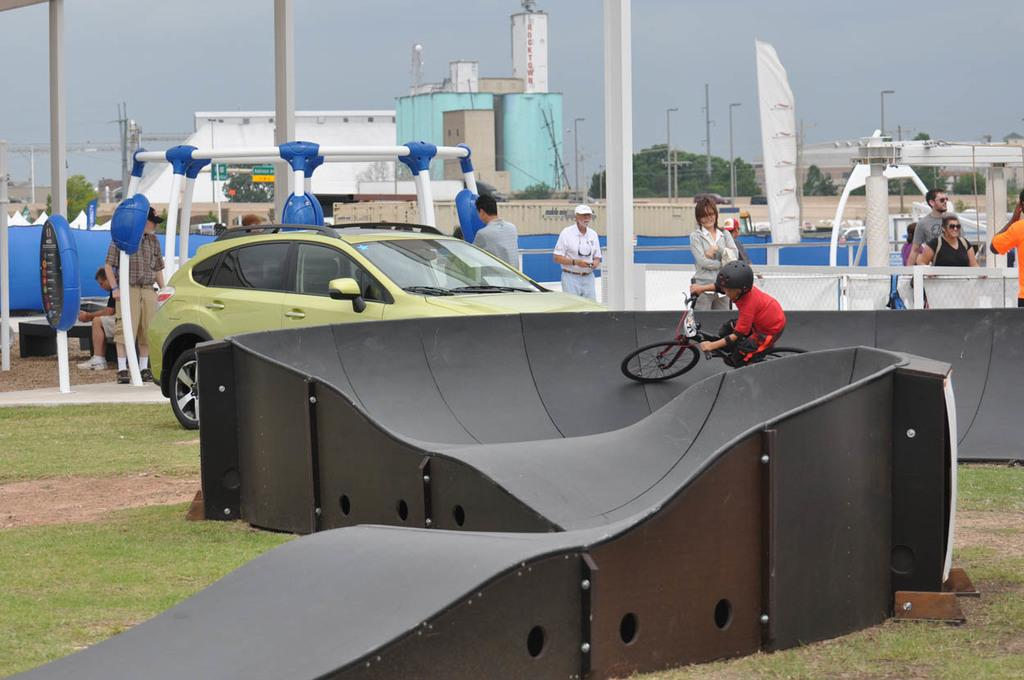What is the main subject of the image? The main subject of the image is a small boy. What is the boy doing in the image? The boy is riding a bicycle in the image. Can you describe the path the boy is riding on? The bicycle is on a curved path, and it is on the grass. What else can be seen in the image besides the boy and the bicycle? There is a car visible in the image, as well as electrical poles and buildings in the background. What type of fang can be seen in the image? There is no fang present in the image. How many apples are visible in the image? There are no apples visible in the image. 